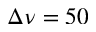Convert formula to latex. <formula><loc_0><loc_0><loc_500><loc_500>\Delta \nu = 5 0</formula> 